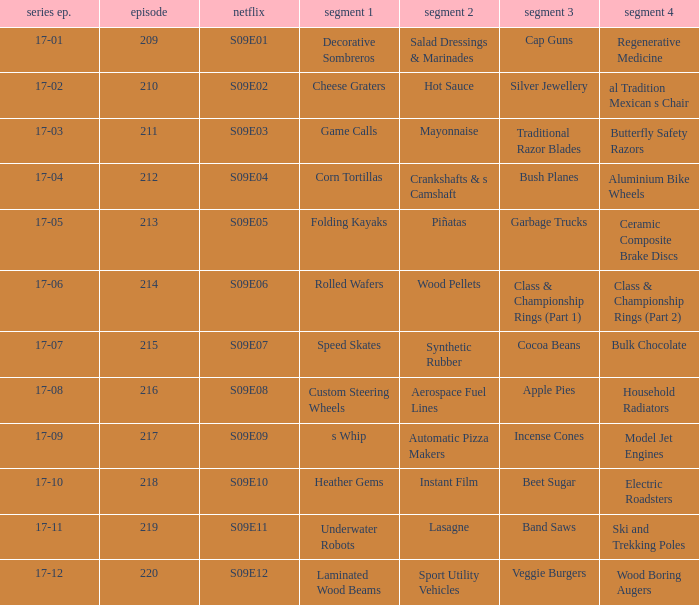For the shows featuring beet sugar, what was on before that Instant Film. 